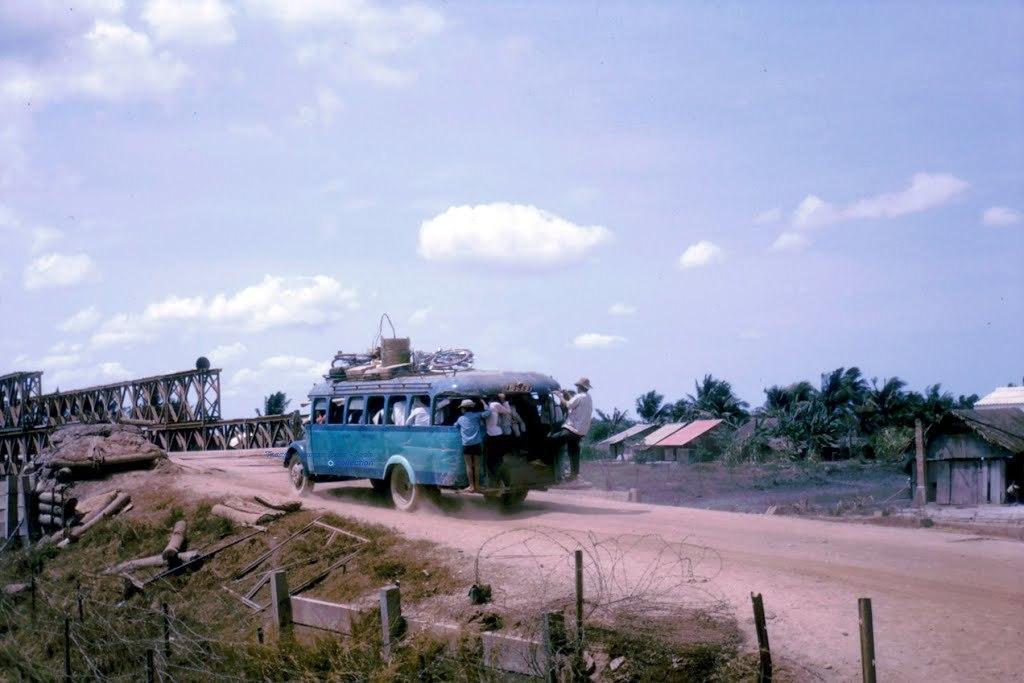How would you summarize this image in a sentence or two? In this image I can see number of trees, few buildings, few poles, fencing, grass, woods, a vehicle, clouds, the sky and here I can see few people are standing. 